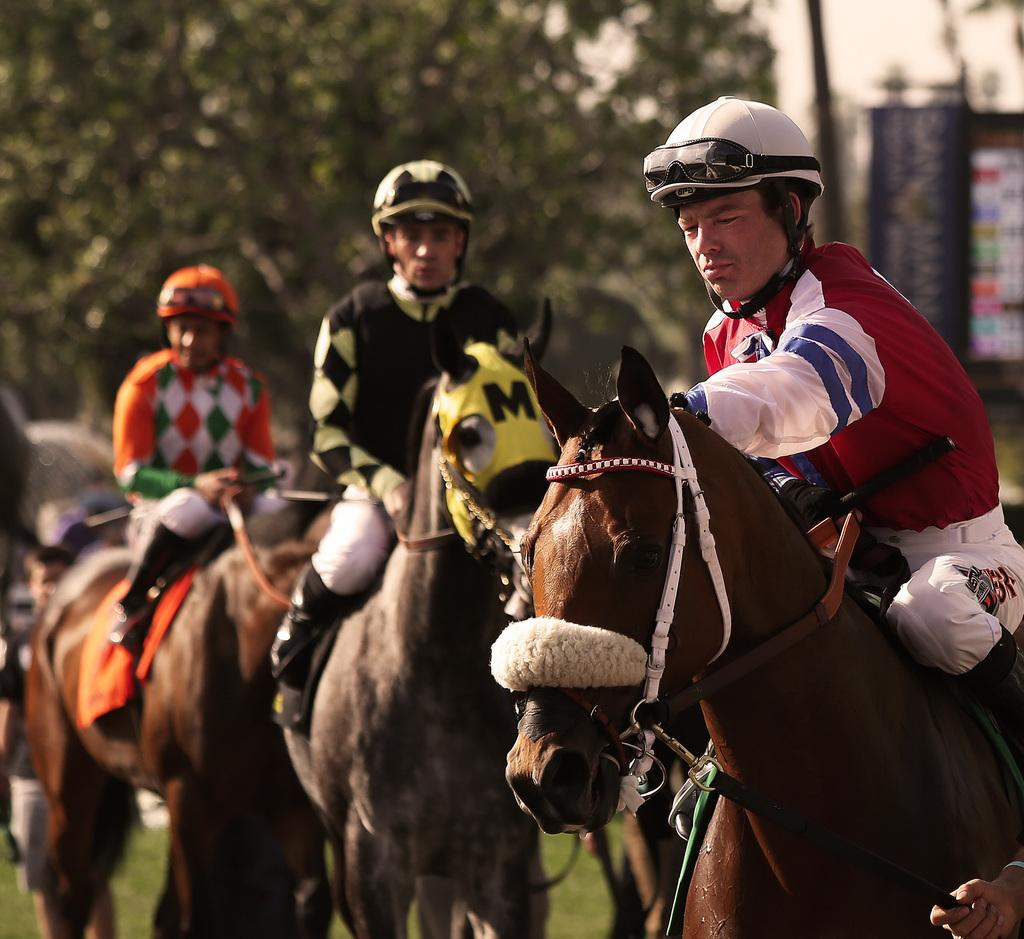How many persons are in the image? There are persons in the image. What are the persons wearing on their heads? The persons are wearing helmets. What are the persons sitting on in the image? The persons are sitting on horses. What can be seen in the background of the image? There are trees in the background of the image. How does the person in the image express their hate for the activity they are participating in? There is no indication in the image that the person is expressing hate for the activity they are participating in. 